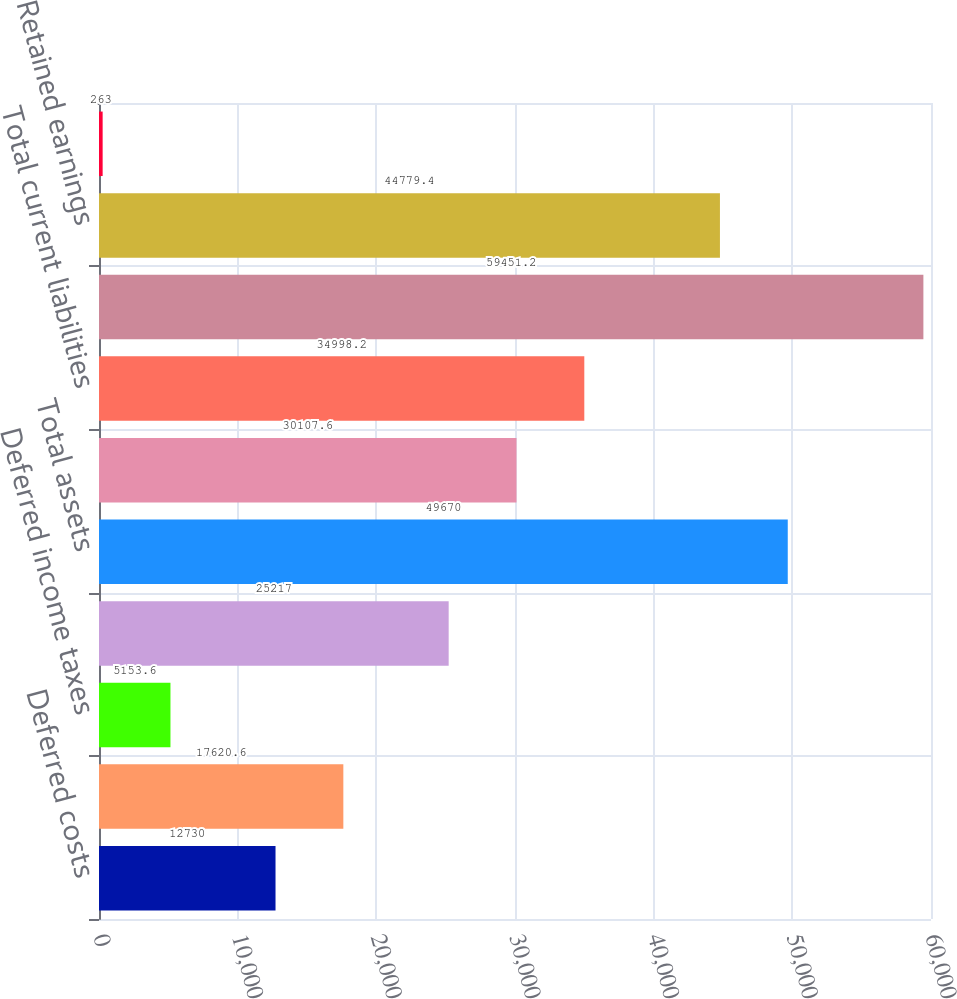Convert chart. <chart><loc_0><loc_0><loc_500><loc_500><bar_chart><fcel>Deferred costs<fcel>Total current assets<fcel>Deferred income taxes<fcel>Noncurrent deferred costs<fcel>Total assets<fcel>Deferred revenue<fcel>Total current liabilities<fcel>Non - current deferred revenue<fcel>Retained earnings<fcel>Accumulated other<nl><fcel>12730<fcel>17620.6<fcel>5153.6<fcel>25217<fcel>49670<fcel>30107.6<fcel>34998.2<fcel>59451.2<fcel>44779.4<fcel>263<nl></chart> 